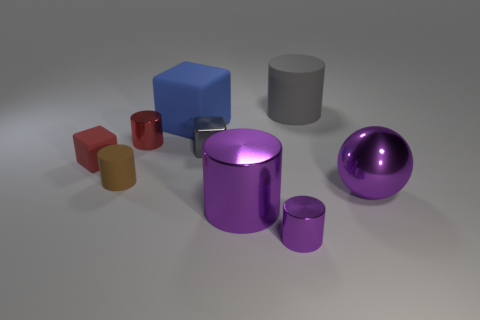Subtract 1 cylinders. How many cylinders are left? 4 Subtract all red cylinders. How many cylinders are left? 4 Subtract all red cylinders. How many cylinders are left? 4 Subtract all cyan cylinders. Subtract all yellow cubes. How many cylinders are left? 5 Add 1 gray shiny objects. How many objects exist? 10 Subtract all balls. How many objects are left? 8 Add 9 small gray objects. How many small gray objects are left? 10 Add 9 purple metal spheres. How many purple metal spheres exist? 10 Subtract 0 gray balls. How many objects are left? 9 Subtract all large things. Subtract all large cyan metallic things. How many objects are left? 5 